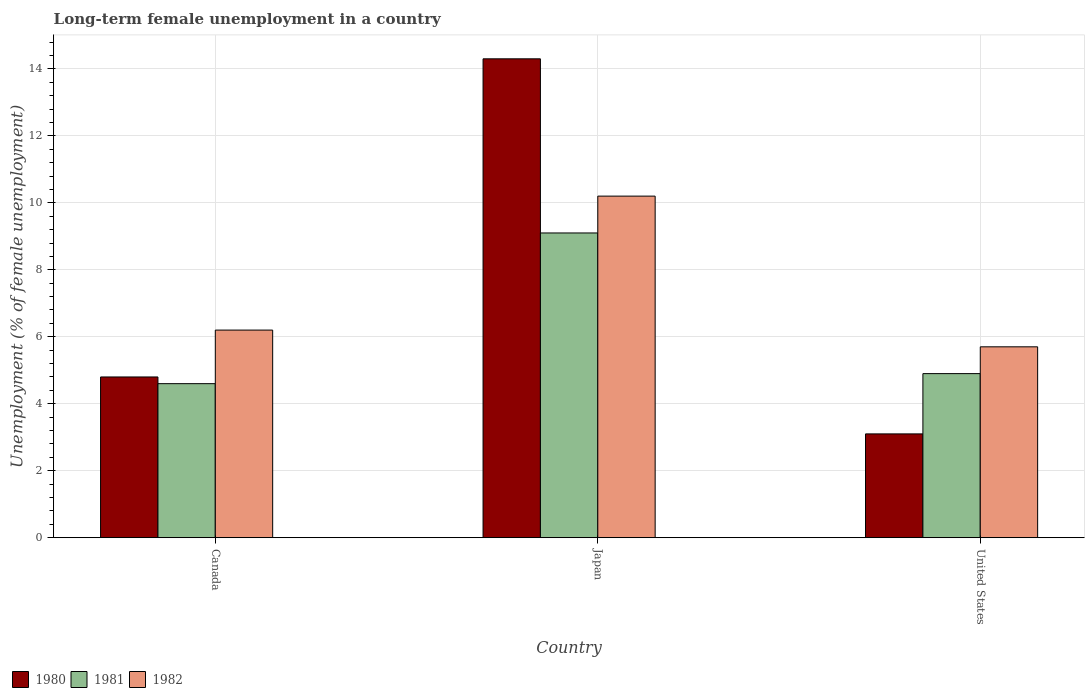How many different coloured bars are there?
Offer a terse response. 3. Are the number of bars on each tick of the X-axis equal?
Your answer should be compact. Yes. How many bars are there on the 2nd tick from the left?
Your answer should be compact. 3. How many bars are there on the 1st tick from the right?
Provide a short and direct response. 3. What is the label of the 1st group of bars from the left?
Your answer should be compact. Canada. What is the percentage of long-term unemployed female population in 1981 in Japan?
Offer a terse response. 9.1. Across all countries, what is the maximum percentage of long-term unemployed female population in 1982?
Provide a short and direct response. 10.2. Across all countries, what is the minimum percentage of long-term unemployed female population in 1982?
Offer a very short reply. 5.7. What is the total percentage of long-term unemployed female population in 1980 in the graph?
Offer a terse response. 22.2. What is the difference between the percentage of long-term unemployed female population in 1980 in Japan and the percentage of long-term unemployed female population in 1982 in United States?
Keep it short and to the point. 8.6. What is the average percentage of long-term unemployed female population in 1980 per country?
Make the answer very short. 7.4. What is the difference between the percentage of long-term unemployed female population of/in 1981 and percentage of long-term unemployed female population of/in 1982 in Japan?
Make the answer very short. -1.1. In how many countries, is the percentage of long-term unemployed female population in 1982 greater than 2.8 %?
Your response must be concise. 3. What is the ratio of the percentage of long-term unemployed female population in 1981 in Japan to that in United States?
Your answer should be compact. 1.86. Is the difference between the percentage of long-term unemployed female population in 1981 in Japan and United States greater than the difference between the percentage of long-term unemployed female population in 1982 in Japan and United States?
Provide a short and direct response. No. What is the difference between the highest and the second highest percentage of long-term unemployed female population in 1980?
Your answer should be very brief. -1.7. What is the difference between the highest and the lowest percentage of long-term unemployed female population in 1982?
Your answer should be compact. 4.5. Is it the case that in every country, the sum of the percentage of long-term unemployed female population in 1980 and percentage of long-term unemployed female population in 1981 is greater than the percentage of long-term unemployed female population in 1982?
Ensure brevity in your answer.  Yes. How many bars are there?
Give a very brief answer. 9. Are all the bars in the graph horizontal?
Make the answer very short. No. What is the difference between two consecutive major ticks on the Y-axis?
Your answer should be very brief. 2. Are the values on the major ticks of Y-axis written in scientific E-notation?
Provide a succinct answer. No. How many legend labels are there?
Offer a very short reply. 3. How are the legend labels stacked?
Your answer should be compact. Horizontal. What is the title of the graph?
Make the answer very short. Long-term female unemployment in a country. Does "1961" appear as one of the legend labels in the graph?
Give a very brief answer. No. What is the label or title of the Y-axis?
Provide a short and direct response. Unemployment (% of female unemployment). What is the Unemployment (% of female unemployment) of 1980 in Canada?
Your answer should be very brief. 4.8. What is the Unemployment (% of female unemployment) of 1981 in Canada?
Keep it short and to the point. 4.6. What is the Unemployment (% of female unemployment) of 1982 in Canada?
Provide a succinct answer. 6.2. What is the Unemployment (% of female unemployment) in 1980 in Japan?
Offer a terse response. 14.3. What is the Unemployment (% of female unemployment) of 1981 in Japan?
Provide a short and direct response. 9.1. What is the Unemployment (% of female unemployment) in 1982 in Japan?
Provide a short and direct response. 10.2. What is the Unemployment (% of female unemployment) of 1980 in United States?
Provide a succinct answer. 3.1. What is the Unemployment (% of female unemployment) in 1981 in United States?
Offer a terse response. 4.9. What is the Unemployment (% of female unemployment) in 1982 in United States?
Ensure brevity in your answer.  5.7. Across all countries, what is the maximum Unemployment (% of female unemployment) in 1980?
Provide a succinct answer. 14.3. Across all countries, what is the maximum Unemployment (% of female unemployment) in 1981?
Ensure brevity in your answer.  9.1. Across all countries, what is the maximum Unemployment (% of female unemployment) in 1982?
Offer a terse response. 10.2. Across all countries, what is the minimum Unemployment (% of female unemployment) of 1980?
Keep it short and to the point. 3.1. Across all countries, what is the minimum Unemployment (% of female unemployment) of 1981?
Provide a succinct answer. 4.6. Across all countries, what is the minimum Unemployment (% of female unemployment) in 1982?
Provide a succinct answer. 5.7. What is the total Unemployment (% of female unemployment) in 1981 in the graph?
Your response must be concise. 18.6. What is the total Unemployment (% of female unemployment) of 1982 in the graph?
Give a very brief answer. 22.1. What is the difference between the Unemployment (% of female unemployment) of 1982 in Canada and that in Japan?
Offer a terse response. -4. What is the difference between the Unemployment (% of female unemployment) of 1981 in Canada and that in United States?
Keep it short and to the point. -0.3. What is the difference between the Unemployment (% of female unemployment) of 1982 in Canada and that in United States?
Your response must be concise. 0.5. What is the difference between the Unemployment (% of female unemployment) of 1981 in Japan and that in United States?
Your answer should be compact. 4.2. What is the difference between the Unemployment (% of female unemployment) of 1980 in Canada and the Unemployment (% of female unemployment) of 1981 in Japan?
Ensure brevity in your answer.  -4.3. What is the difference between the Unemployment (% of female unemployment) in 1980 in Canada and the Unemployment (% of female unemployment) in 1982 in Japan?
Your answer should be very brief. -5.4. What is the difference between the Unemployment (% of female unemployment) in 1981 in Canada and the Unemployment (% of female unemployment) in 1982 in Japan?
Your answer should be very brief. -5.6. What is the difference between the Unemployment (% of female unemployment) in 1980 in Japan and the Unemployment (% of female unemployment) in 1981 in United States?
Your answer should be very brief. 9.4. What is the difference between the Unemployment (% of female unemployment) in 1980 in Japan and the Unemployment (% of female unemployment) in 1982 in United States?
Provide a succinct answer. 8.6. What is the average Unemployment (% of female unemployment) of 1980 per country?
Offer a terse response. 7.4. What is the average Unemployment (% of female unemployment) of 1981 per country?
Keep it short and to the point. 6.2. What is the average Unemployment (% of female unemployment) of 1982 per country?
Offer a very short reply. 7.37. What is the difference between the Unemployment (% of female unemployment) of 1980 and Unemployment (% of female unemployment) of 1982 in Canada?
Give a very brief answer. -1.4. What is the difference between the Unemployment (% of female unemployment) of 1981 and Unemployment (% of female unemployment) of 1982 in Canada?
Your response must be concise. -1.6. What is the difference between the Unemployment (% of female unemployment) of 1981 and Unemployment (% of female unemployment) of 1982 in Japan?
Provide a succinct answer. -1.1. What is the difference between the Unemployment (% of female unemployment) of 1980 and Unemployment (% of female unemployment) of 1981 in United States?
Your answer should be very brief. -1.8. What is the difference between the Unemployment (% of female unemployment) in 1981 and Unemployment (% of female unemployment) in 1982 in United States?
Your answer should be very brief. -0.8. What is the ratio of the Unemployment (% of female unemployment) of 1980 in Canada to that in Japan?
Ensure brevity in your answer.  0.34. What is the ratio of the Unemployment (% of female unemployment) in 1981 in Canada to that in Japan?
Your response must be concise. 0.51. What is the ratio of the Unemployment (% of female unemployment) of 1982 in Canada to that in Japan?
Keep it short and to the point. 0.61. What is the ratio of the Unemployment (% of female unemployment) in 1980 in Canada to that in United States?
Keep it short and to the point. 1.55. What is the ratio of the Unemployment (% of female unemployment) in 1981 in Canada to that in United States?
Provide a short and direct response. 0.94. What is the ratio of the Unemployment (% of female unemployment) of 1982 in Canada to that in United States?
Keep it short and to the point. 1.09. What is the ratio of the Unemployment (% of female unemployment) in 1980 in Japan to that in United States?
Keep it short and to the point. 4.61. What is the ratio of the Unemployment (% of female unemployment) in 1981 in Japan to that in United States?
Ensure brevity in your answer.  1.86. What is the ratio of the Unemployment (% of female unemployment) of 1982 in Japan to that in United States?
Make the answer very short. 1.79. What is the difference between the highest and the second highest Unemployment (% of female unemployment) of 1980?
Provide a short and direct response. 9.5. What is the difference between the highest and the second highest Unemployment (% of female unemployment) in 1981?
Ensure brevity in your answer.  4.2. What is the difference between the highest and the second highest Unemployment (% of female unemployment) in 1982?
Ensure brevity in your answer.  4. What is the difference between the highest and the lowest Unemployment (% of female unemployment) in 1981?
Your response must be concise. 4.5. 